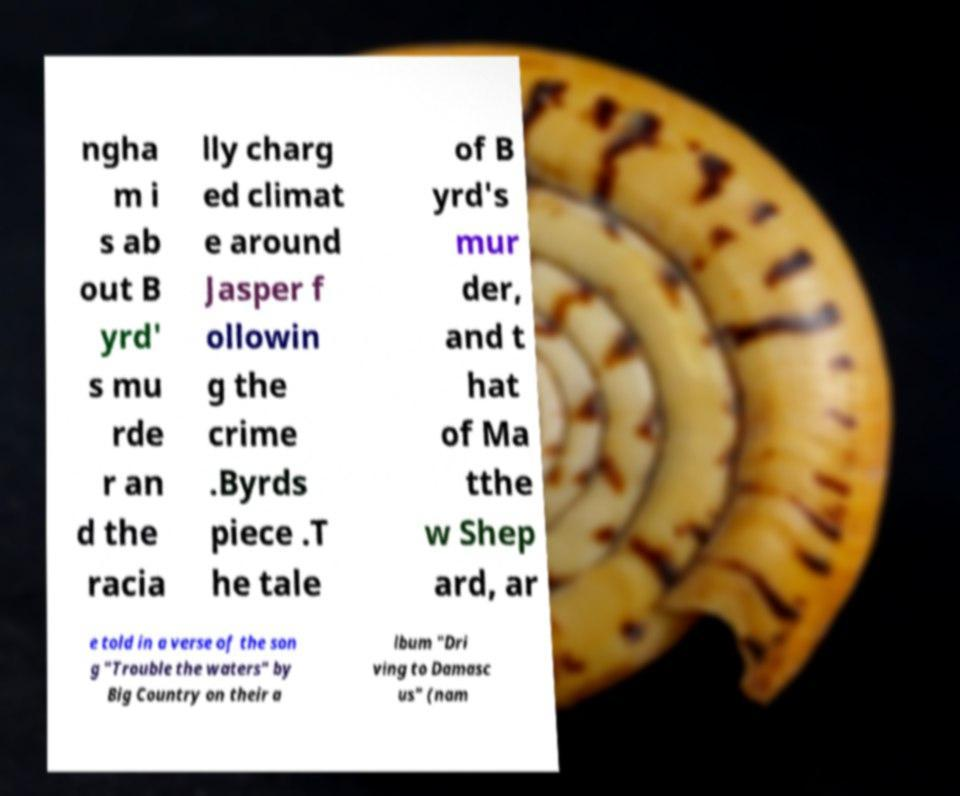Please identify and transcribe the text found in this image. ngha m i s ab out B yrd' s mu rde r an d the racia lly charg ed climat e around Jasper f ollowin g the crime .Byrds piece .T he tale of B yrd's mur der, and t hat of Ma tthe w Shep ard, ar e told in a verse of the son g "Trouble the waters" by Big Country on their a lbum "Dri ving to Damasc us" (nam 